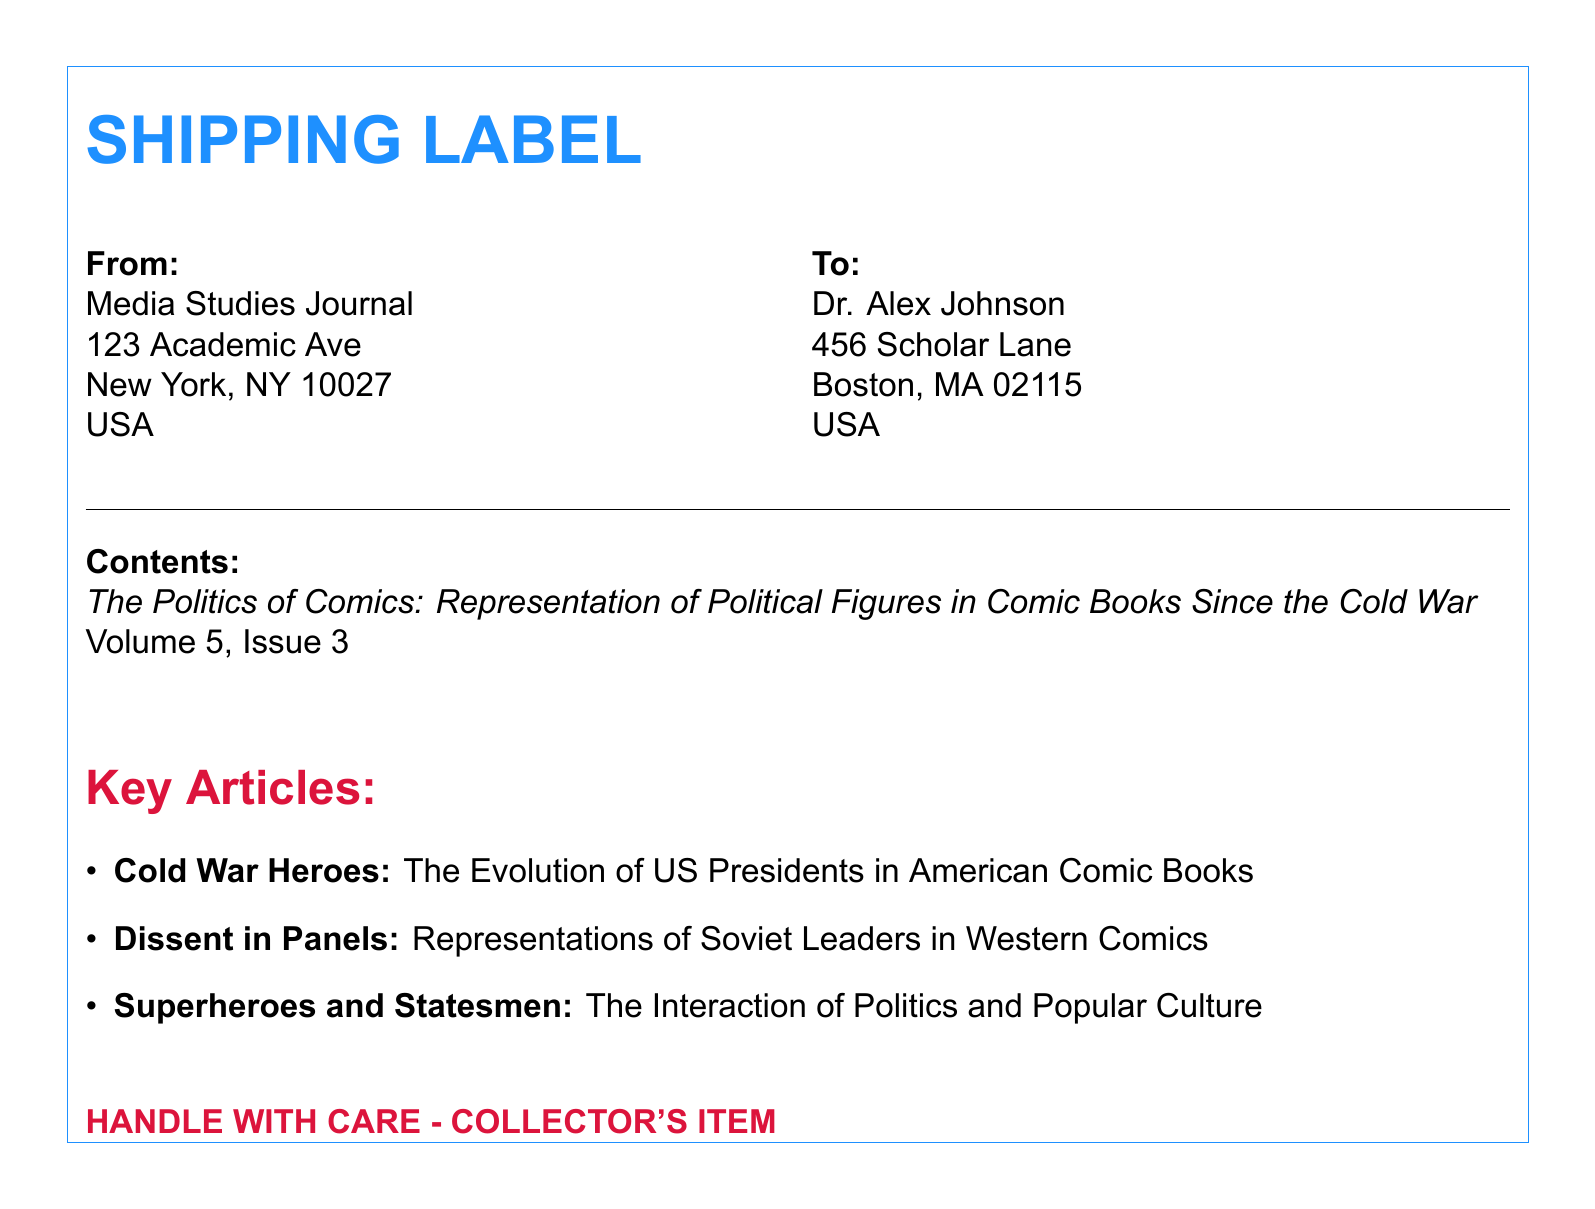What is the title of the magazine issue? The title is specified in the document as the focus of the contents section detailing the topic of the collectible magazine issue.
Answer: The Politics of Comics: Representation of Political Figures in Comic Books Since the Cold War What is the issue number? The issue number is found in the references made to the volume and issue within the document.
Answer: Volume 5, Issue 3 Who is the recipient's name? The recipient's name is provided clearly in the "To:" section of the shipping label.
Answer: Dr. Alex Johnson What is the name of the sender organization? The sending organization is specifically mentioned at the beginning of the "From:" section of the shipping label.
Answer: Media Studies Journal What does the label indicate about the item? The label includes a specific phrase that alerts handlers about the nature of the contents.
Answer: HANDLE WITH CARE - COLLECTOR'S ITEM What city is the sender located in? The city associated with the sender's address is highlighted in the corresponding section of the shipping label.
Answer: New York What are the colors used for the title? The title is presented using a specific color scheme that is clearly defined in the document using RGB values.
Answer: comicblue How many key articles are listed? The number of key articles can be determined by counting the items in the listed section within the document.
Answer: 3 What street address does Dr. Alex Johnson live on? The residential street address of the recipient is explicitly written in the "To:" section of the shipping label.
Answer: 456 Scholar Lane What is the focus of the article about US Presidents? The specific focus of this key article, as indicated by its title, can be inferred from the document.
Answer: The Evolution of US Presidents in American Comic Books 